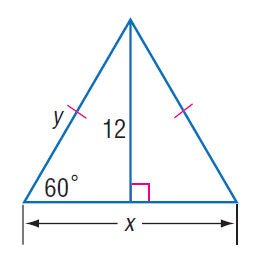Answer the mathemtical geometry problem and directly provide the correct option letter.
Question: Find y.
Choices: A: 4 \sqrt { 3 } B: 8 C: 8 \sqrt { 3 } D: 16 C 